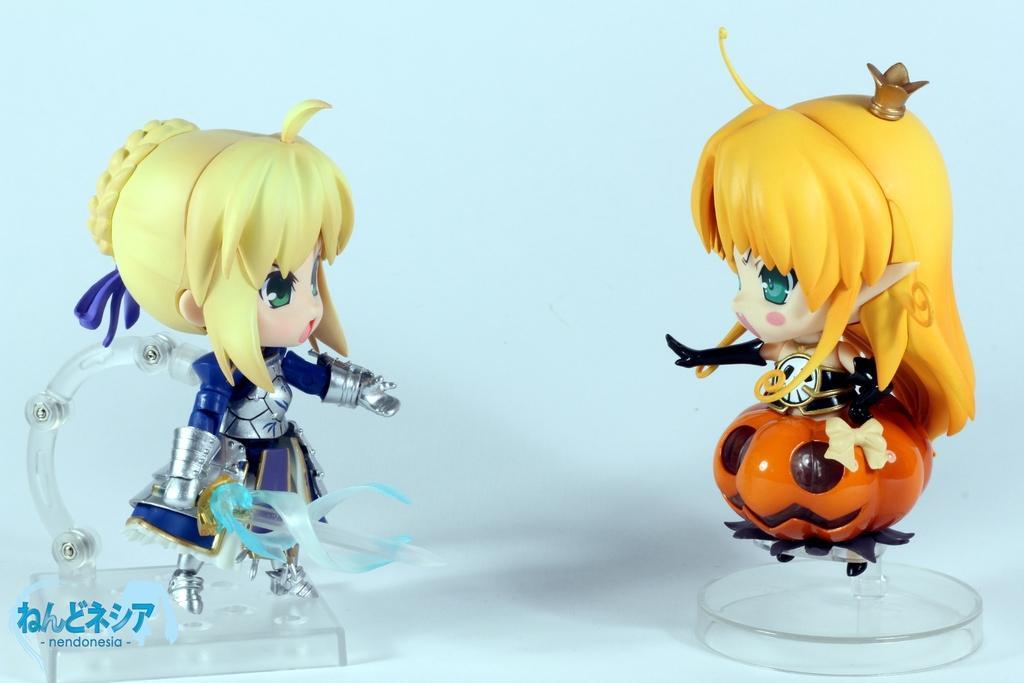Please provide a concise description of this image. There are two toys kept on a white color surface as we can see in the middle of this image, and there is a watermark at the bottom left corner of this image. 